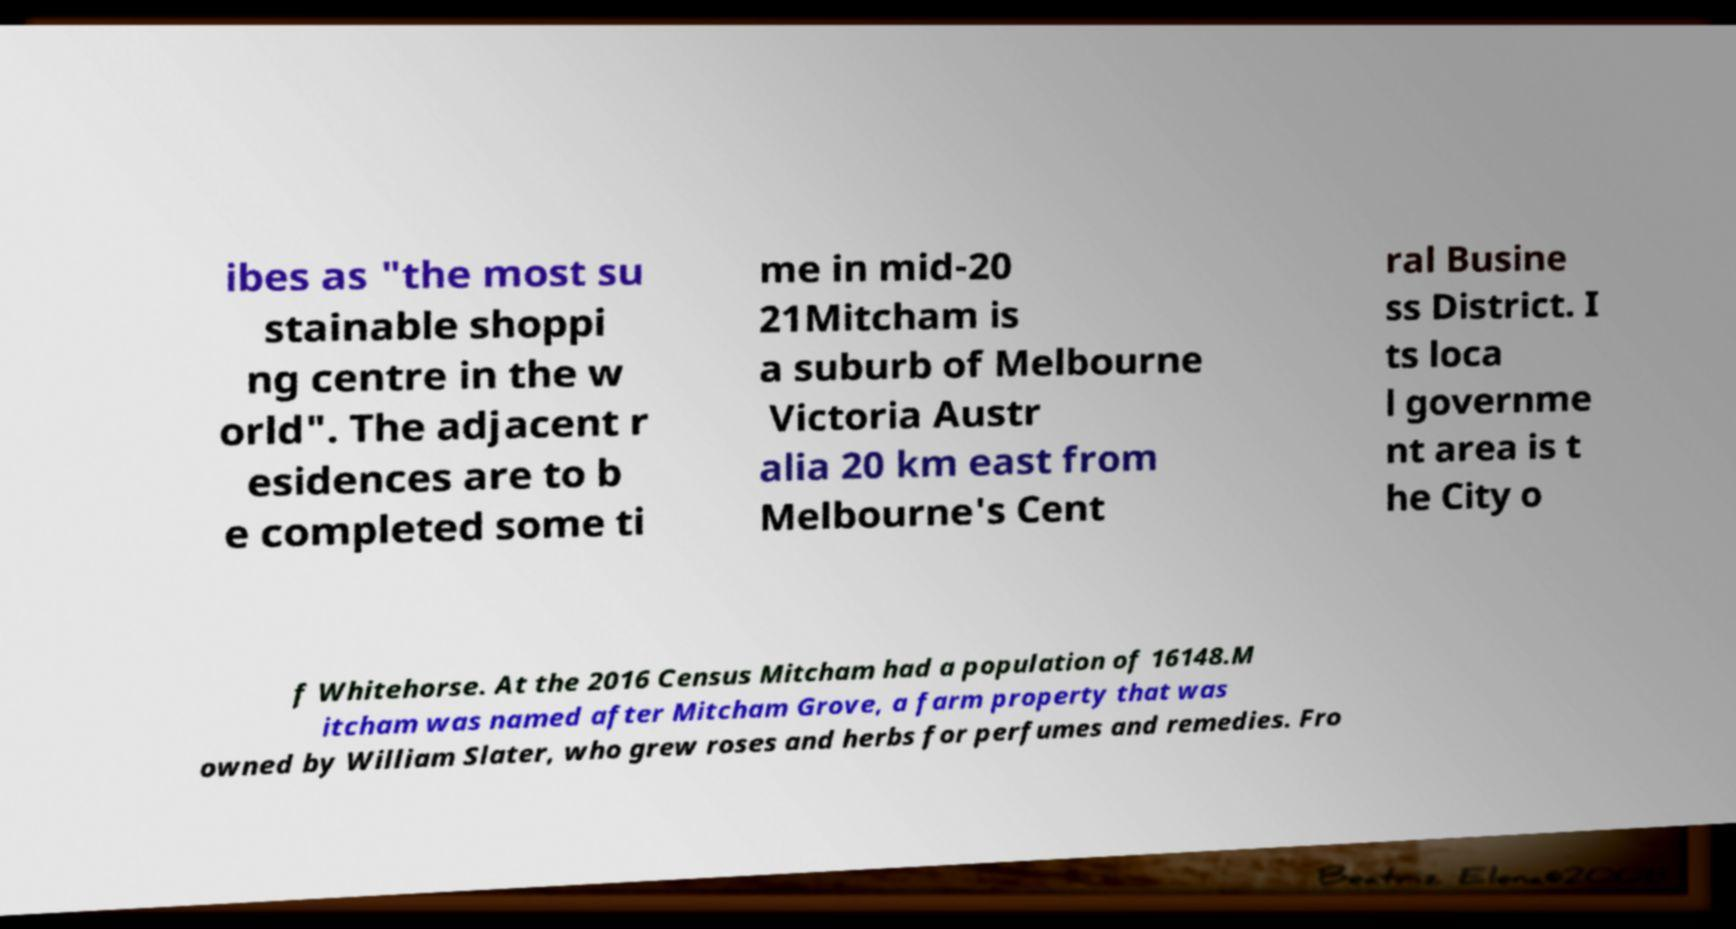I need the written content from this picture converted into text. Can you do that? ibes as "the most su stainable shoppi ng centre in the w orld". The adjacent r esidences are to b e completed some ti me in mid-20 21Mitcham is a suburb of Melbourne Victoria Austr alia 20 km east from Melbourne's Cent ral Busine ss District. I ts loca l governme nt area is t he City o f Whitehorse. At the 2016 Census Mitcham had a population of 16148.M itcham was named after Mitcham Grove, a farm property that was owned by William Slater, who grew roses and herbs for perfumes and remedies. Fro 